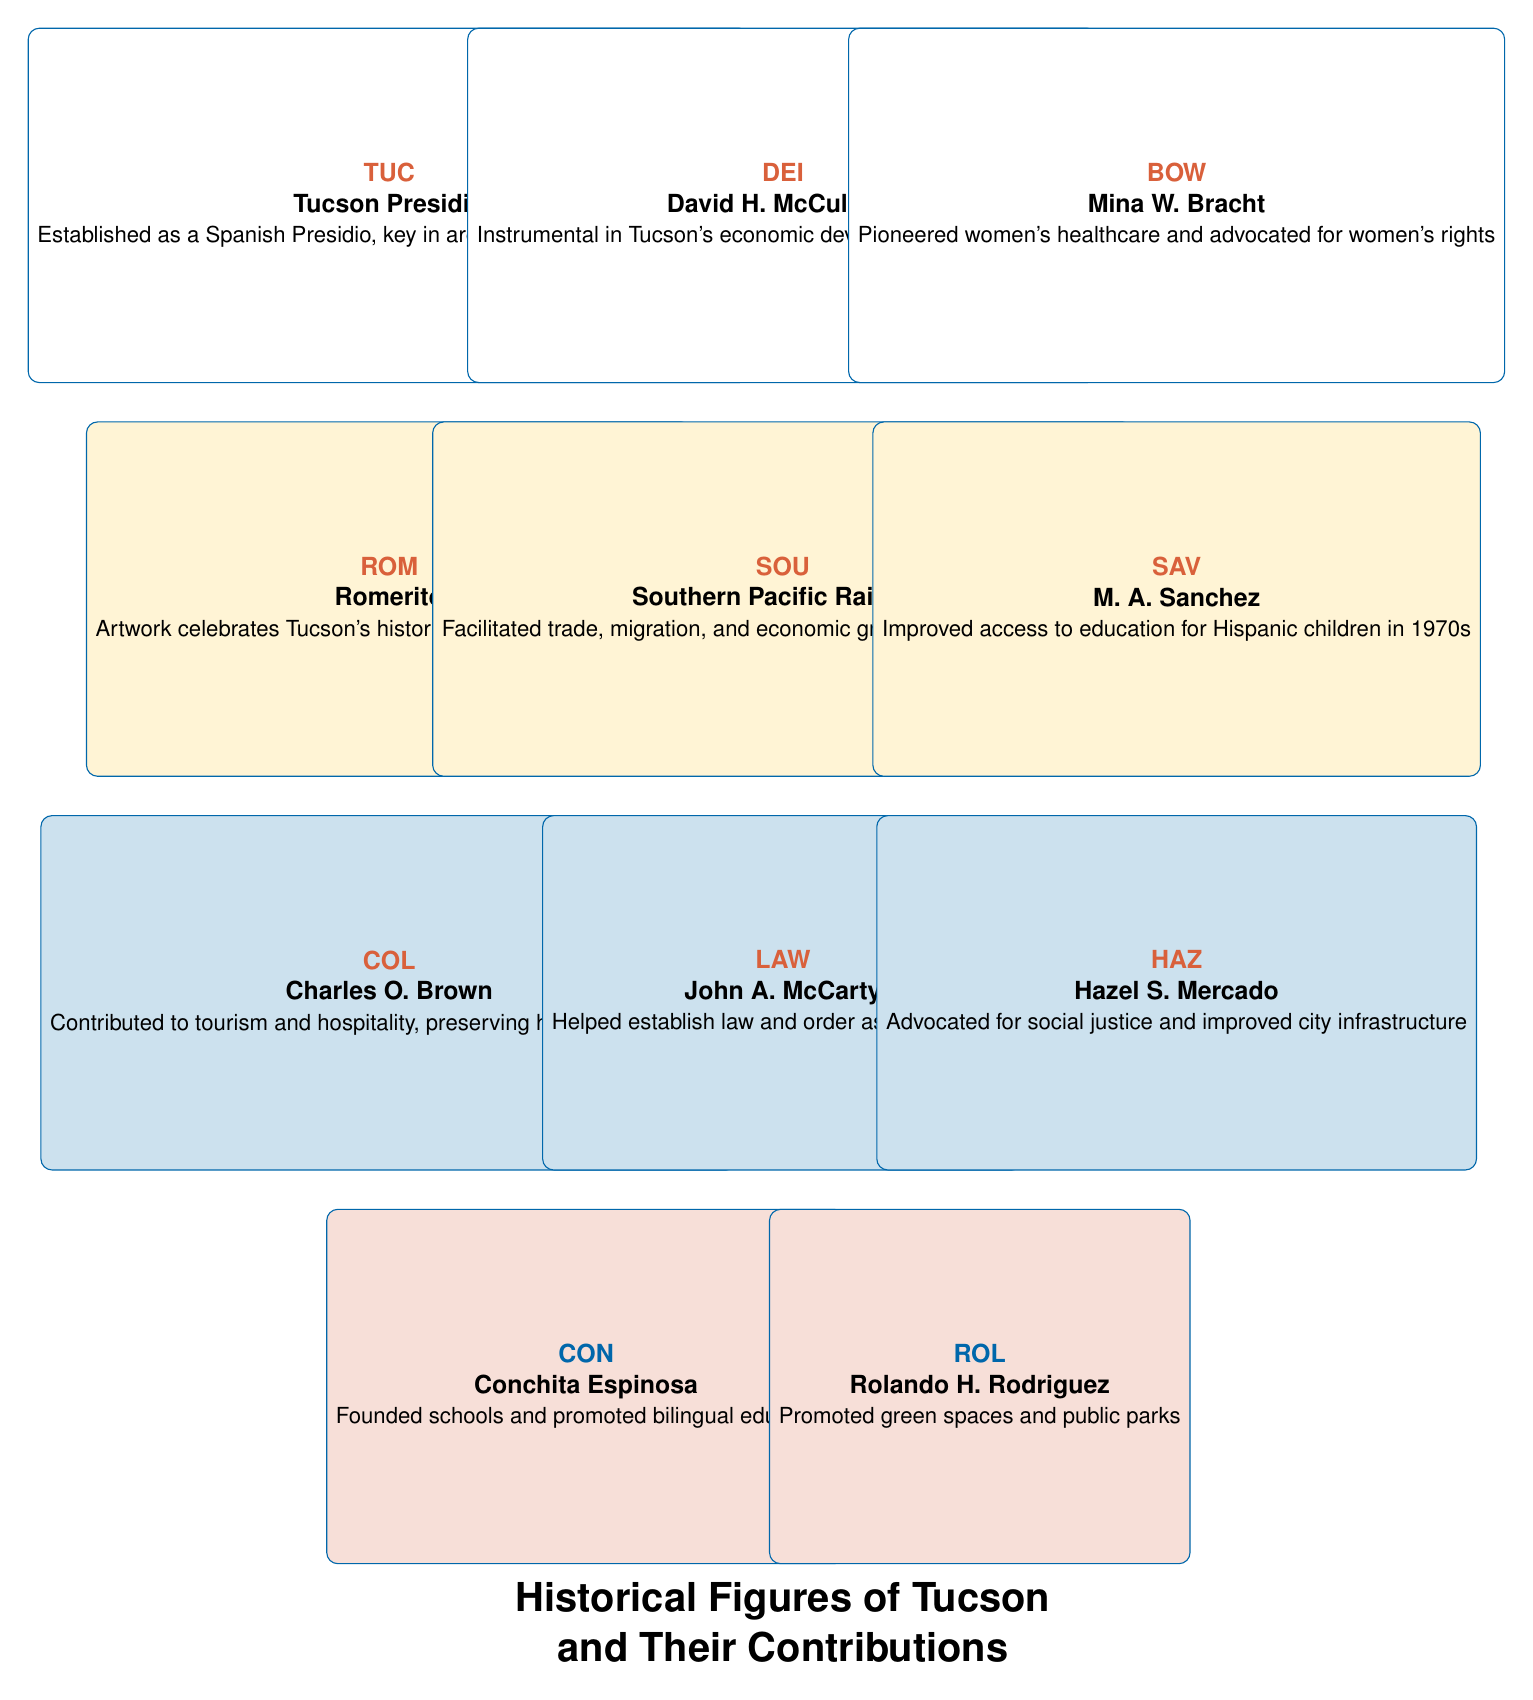What is the contribution of Mina W. Bracht? The contribution of Mina W. Bracht is that she pioneered women's healthcare in the region and advocated for women's rights, as noted in her description in the table.
Answer: She pioneered women's healthcare and advocated for women's rights Who was the first Hispanic woman elected to the Tucson City Council? The table states that Hazel S. Mercado was the first Hispanic woman elected to the Tucson City Council in the 1980s, confirming her title as the first.
Answer: Hazel S. Mercado What role did the Southern Pacific Railroad play in Tucson's development? The Southern Pacific Railroad facilitated trade, migration, and economic growth in Tucson and Southern Arizona according to its contribution listed in the table.
Answer: It facilitated trade, migration, and economic growth How many individuals in the table contributed to healthcare? The table lists two individuals related to healthcare: Mina W. Bracht, who pioneered women's healthcare, and Conchita Espinosa, who impacted education which can include health education. Thus, there are two contributors explicitly connected to healthcare.
Answer: Two individuals Is Conchita Espinosa associated with bilingual education? Yes, the contribution of Conchita Espinosa emphasizes that she promoted bilingual education, as stated in her description in the table.
Answer: Yes Which historical figure contributed to urban development and sustainability? According to the table, Rolando H. Rodriguez focused on urban development and sustainability, which is clearly stated in his contribution.
Answer: Rolando H. Rodriguez Provide the names of the individuals who played a role in Tucson’s economic development. Three individuals can be identified from the table: David H. McCulloch, who was instrumental in economic development post-Civil War; the Southern Pacific Railroad, which boosted economic growth; and Charles O. Brown, who contributed to tourism.
Answer: David H. McCulloch, Southern Pacific Railroad, Charles O. Brown What were the main contributions of John A. McCarty? John A. McCarty's contributions included helping establish law and order in Tucson as it grew, making him a significant figure in law enforcement during the late 1800s.
Answer: Established law and order in Tucson 